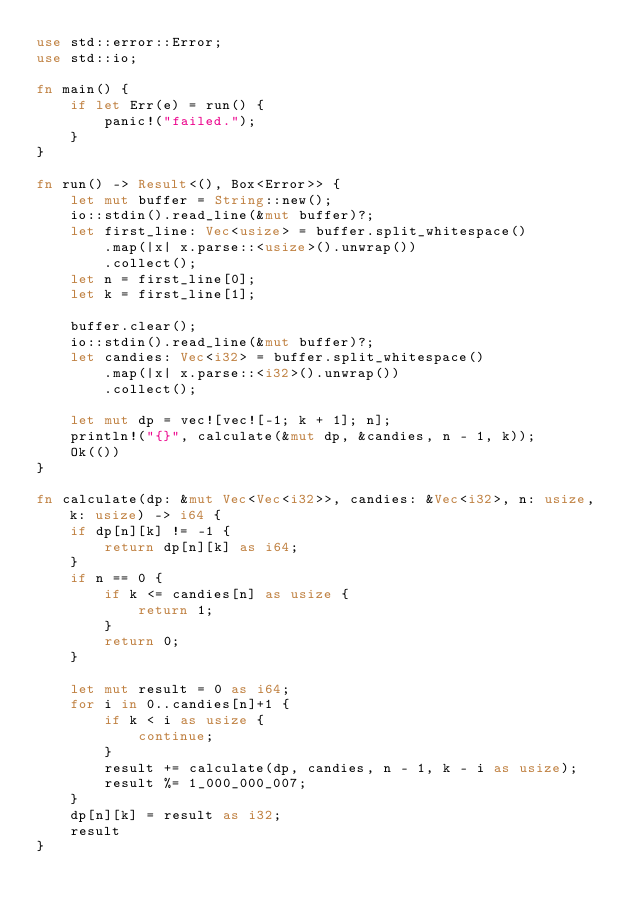Convert code to text. <code><loc_0><loc_0><loc_500><loc_500><_Rust_>use std::error::Error;
use std::io;

fn main() {
    if let Err(e) = run() {
        panic!("failed.");
    }
}

fn run() -> Result<(), Box<Error>> {
    let mut buffer = String::new();
    io::stdin().read_line(&mut buffer)?;
    let first_line: Vec<usize> = buffer.split_whitespace()
        .map(|x| x.parse::<usize>().unwrap())
        .collect();
    let n = first_line[0];
    let k = first_line[1];

    buffer.clear();
    io::stdin().read_line(&mut buffer)?;
    let candies: Vec<i32> = buffer.split_whitespace()
        .map(|x| x.parse::<i32>().unwrap())
        .collect();

    let mut dp = vec![vec![-1; k + 1]; n];
    println!("{}", calculate(&mut dp, &candies, n - 1, k));
    Ok(())
}

fn calculate(dp: &mut Vec<Vec<i32>>, candies: &Vec<i32>, n: usize, k: usize) -> i64 {
    if dp[n][k] != -1 {
        return dp[n][k] as i64;
    }
    if n == 0 {
        if k <= candies[n] as usize {
            return 1;
        }
        return 0;
    }

    let mut result = 0 as i64;
    for i in 0..candies[n]+1 {
        if k < i as usize {
            continue;
        }
        result += calculate(dp, candies, n - 1, k - i as usize);
        result %= 1_000_000_007;
    }
    dp[n][k] = result as i32;
    result
}
</code> 